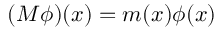Convert formula to latex. <formula><loc_0><loc_0><loc_500><loc_500>( M \phi ) ( x ) = m ( x ) \phi ( x )</formula> 